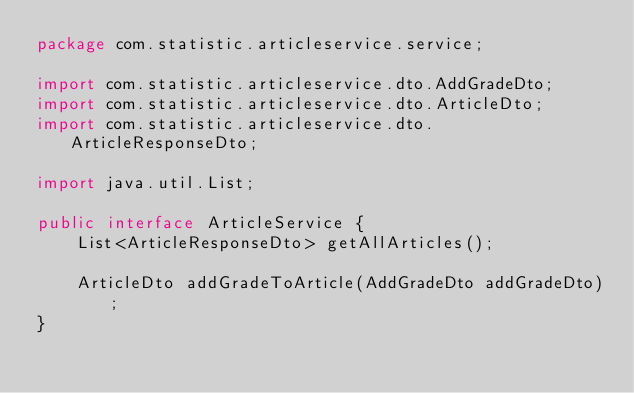Convert code to text. <code><loc_0><loc_0><loc_500><loc_500><_Java_>package com.statistic.articleservice.service;

import com.statistic.articleservice.dto.AddGradeDto;
import com.statistic.articleservice.dto.ArticleDto;
import com.statistic.articleservice.dto.ArticleResponseDto;

import java.util.List;

public interface ArticleService {
    List<ArticleResponseDto> getAllArticles();

    ArticleDto addGradeToArticle(AddGradeDto addGradeDto);
}
</code> 